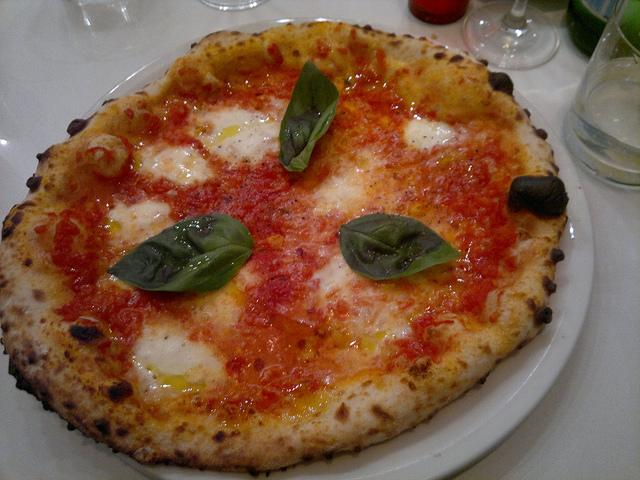Which one of these cheeses is rarely seen on this dish?

Choices:
A) mozzarella
B) american
C) parmesan
D) provolone american 